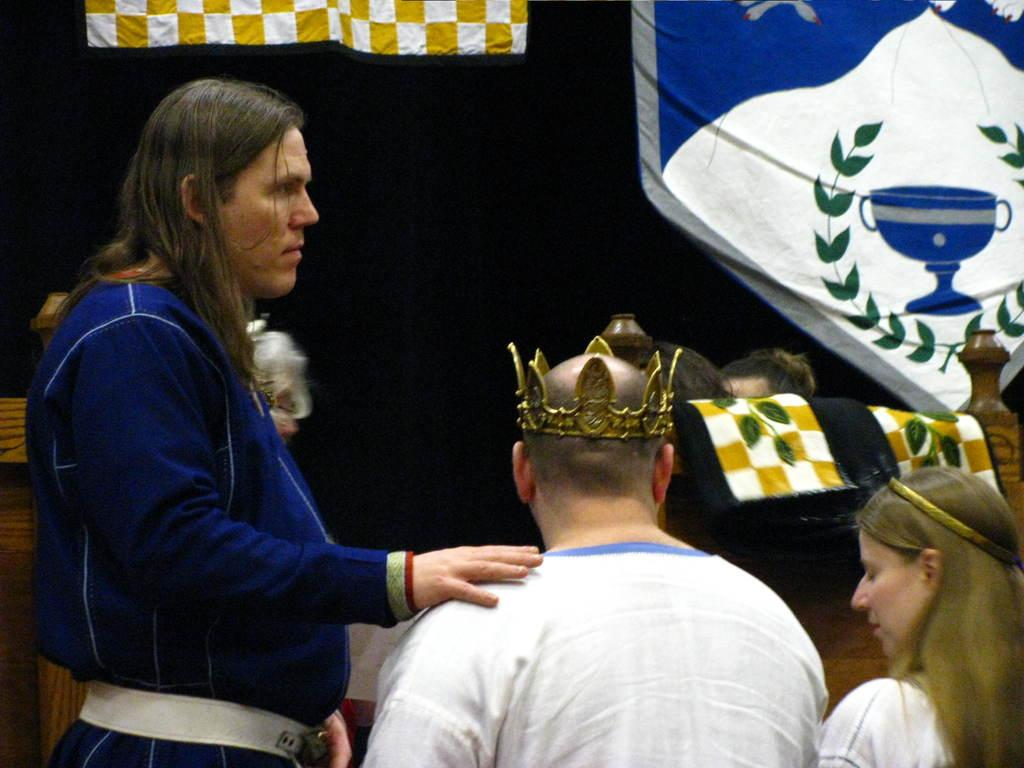Who or what can be seen in the image? There are people in the image. What is the most prominent accessory in the image? There is a crown in the image. What type of items are visible in the image? There are clothes and unspecified objects in the image. How would you describe the lighting in the image? The background of the image is dark. How many snails can be seen crawling on the clothes in the image? There are no snails present in the image; it features people, a crown, and unspecified objects. What type of light source is used to illuminate the image? The provided facts do not mention any light source; the image is described as having a dark background. 